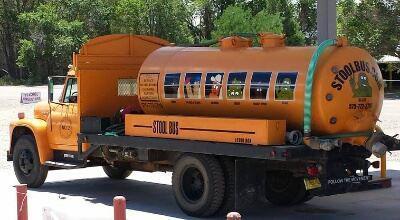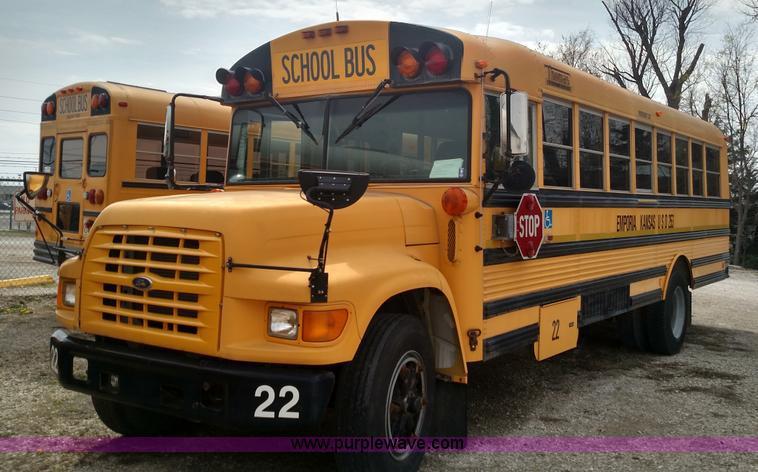The first image is the image on the left, the second image is the image on the right. Assess this claim about the two images: "One of the buses is a traditional yellow color while the other is more of a reddish hue.". Correct or not? Answer yes or no. No. The first image is the image on the left, the second image is the image on the right. Examine the images to the left and right. Is the description "The right image contains a red-orange bus angled facing rightward." accurate? Answer yes or no. No. 